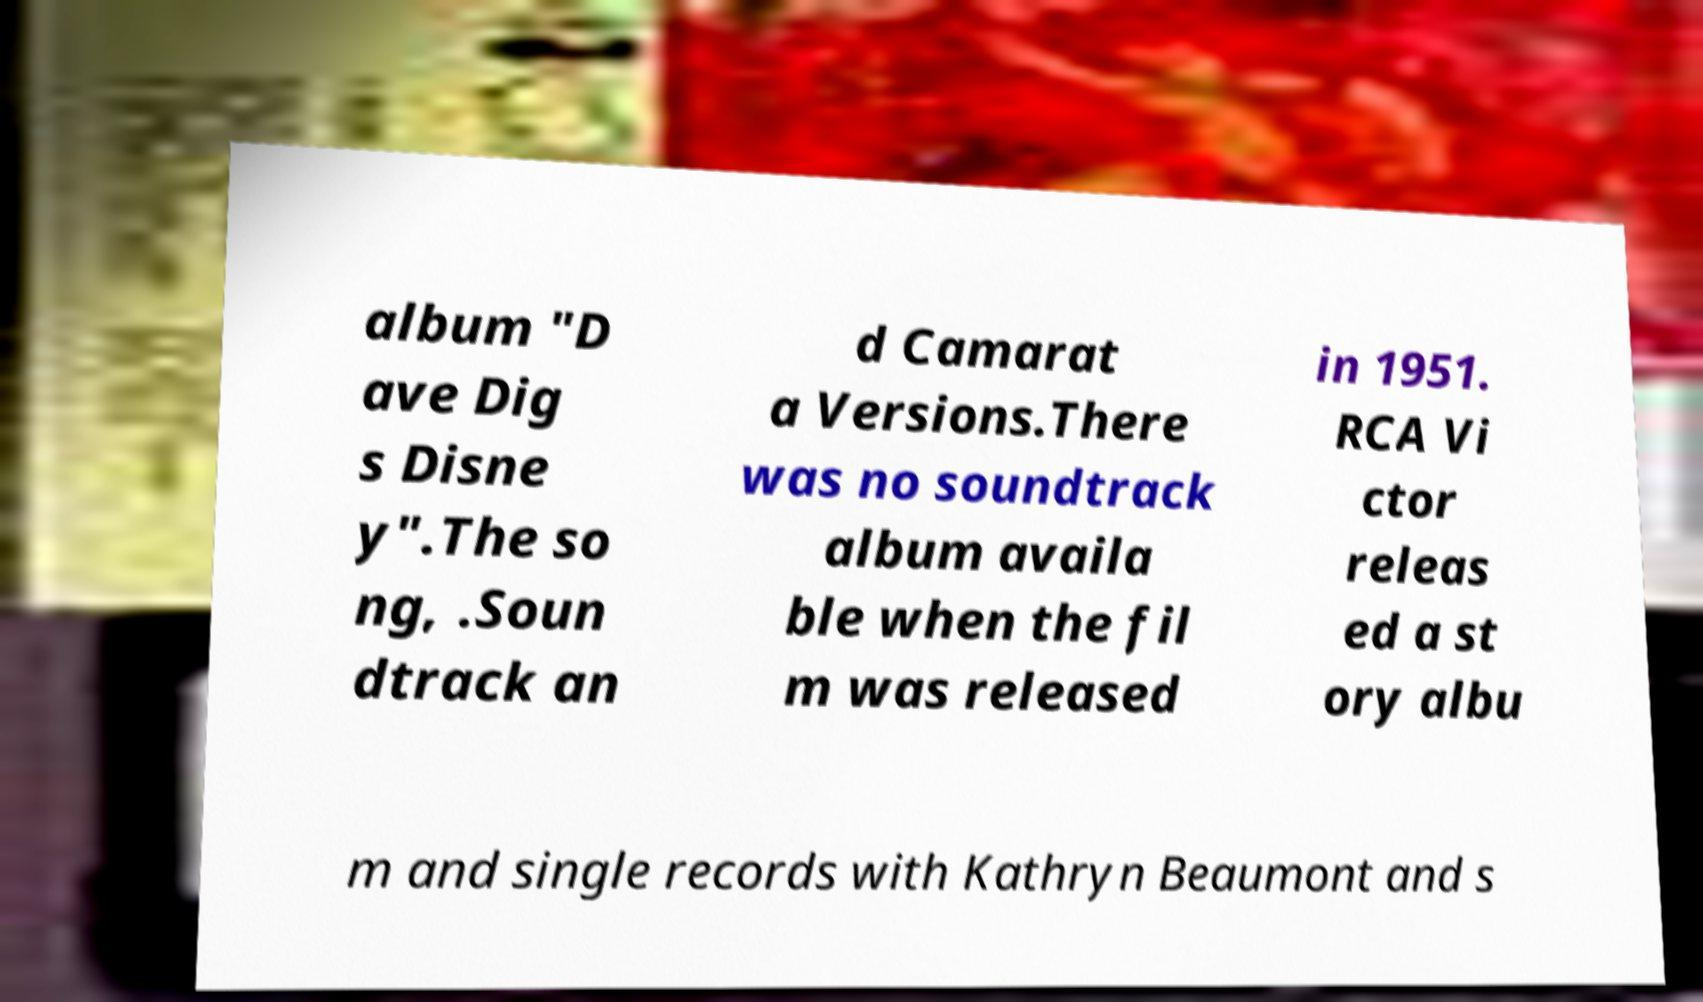Can you read and provide the text displayed in the image?This photo seems to have some interesting text. Can you extract and type it out for me? album "D ave Dig s Disne y".The so ng, .Soun dtrack an d Camarat a Versions.There was no soundtrack album availa ble when the fil m was released in 1951. RCA Vi ctor releas ed a st ory albu m and single records with Kathryn Beaumont and s 